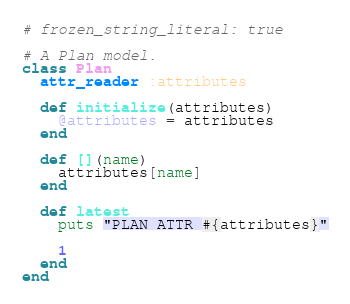Convert code to text. <code><loc_0><loc_0><loc_500><loc_500><_Ruby_># frozen_string_literal: true

# A Plan model.
class Plan
  attr_reader :attributes

  def initialize(attributes)
    @attributes = attributes
  end

  def [](name)
    attributes[name]
  end

  def latest
    puts "PLAN ATTR #{attributes}"

    1
  end
end
</code> 